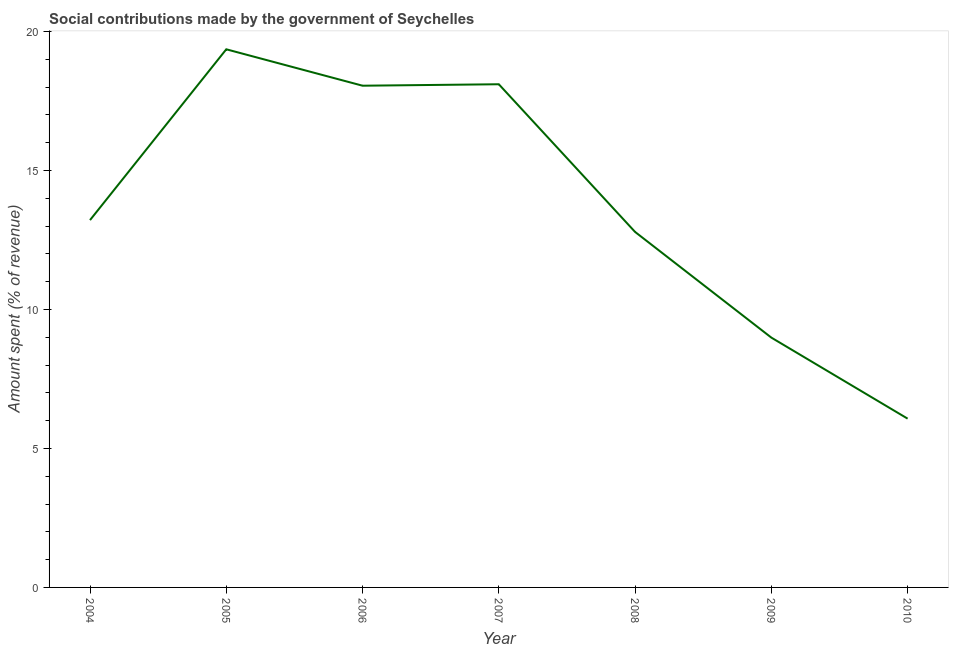What is the amount spent in making social contributions in 2008?
Give a very brief answer. 12.79. Across all years, what is the maximum amount spent in making social contributions?
Your answer should be compact. 19.36. Across all years, what is the minimum amount spent in making social contributions?
Provide a succinct answer. 6.07. In which year was the amount spent in making social contributions maximum?
Give a very brief answer. 2005. What is the sum of the amount spent in making social contributions?
Provide a short and direct response. 96.59. What is the difference between the amount spent in making social contributions in 2007 and 2010?
Give a very brief answer. 12.03. What is the average amount spent in making social contributions per year?
Offer a terse response. 13.8. What is the median amount spent in making social contributions?
Ensure brevity in your answer.  13.22. In how many years, is the amount spent in making social contributions greater than 1 %?
Provide a succinct answer. 7. What is the ratio of the amount spent in making social contributions in 2005 to that in 2006?
Provide a short and direct response. 1.07. Is the amount spent in making social contributions in 2007 less than that in 2010?
Offer a terse response. No. What is the difference between the highest and the second highest amount spent in making social contributions?
Offer a terse response. 1.26. What is the difference between the highest and the lowest amount spent in making social contributions?
Offer a terse response. 13.29. Does the amount spent in making social contributions monotonically increase over the years?
Provide a succinct answer. No. How many lines are there?
Your response must be concise. 1. What is the difference between two consecutive major ticks on the Y-axis?
Make the answer very short. 5. Are the values on the major ticks of Y-axis written in scientific E-notation?
Give a very brief answer. No. Does the graph contain grids?
Offer a terse response. No. What is the title of the graph?
Provide a succinct answer. Social contributions made by the government of Seychelles. What is the label or title of the Y-axis?
Keep it short and to the point. Amount spent (% of revenue). What is the Amount spent (% of revenue) in 2004?
Provide a succinct answer. 13.22. What is the Amount spent (% of revenue) in 2005?
Your answer should be compact. 19.36. What is the Amount spent (% of revenue) in 2006?
Ensure brevity in your answer.  18.05. What is the Amount spent (% of revenue) of 2007?
Make the answer very short. 18.1. What is the Amount spent (% of revenue) of 2008?
Offer a terse response. 12.79. What is the Amount spent (% of revenue) of 2009?
Offer a very short reply. 8.99. What is the Amount spent (% of revenue) in 2010?
Your answer should be very brief. 6.07. What is the difference between the Amount spent (% of revenue) in 2004 and 2005?
Offer a terse response. -6.15. What is the difference between the Amount spent (% of revenue) in 2004 and 2006?
Offer a terse response. -4.84. What is the difference between the Amount spent (% of revenue) in 2004 and 2007?
Your response must be concise. -4.89. What is the difference between the Amount spent (% of revenue) in 2004 and 2008?
Provide a short and direct response. 0.43. What is the difference between the Amount spent (% of revenue) in 2004 and 2009?
Ensure brevity in your answer.  4.23. What is the difference between the Amount spent (% of revenue) in 2004 and 2010?
Provide a short and direct response. 7.14. What is the difference between the Amount spent (% of revenue) in 2005 and 2006?
Offer a very short reply. 1.31. What is the difference between the Amount spent (% of revenue) in 2005 and 2007?
Make the answer very short. 1.26. What is the difference between the Amount spent (% of revenue) in 2005 and 2008?
Provide a succinct answer. 6.57. What is the difference between the Amount spent (% of revenue) in 2005 and 2009?
Your answer should be compact. 10.37. What is the difference between the Amount spent (% of revenue) in 2005 and 2010?
Your response must be concise. 13.29. What is the difference between the Amount spent (% of revenue) in 2006 and 2007?
Give a very brief answer. -0.05. What is the difference between the Amount spent (% of revenue) in 2006 and 2008?
Your answer should be very brief. 5.26. What is the difference between the Amount spent (% of revenue) in 2006 and 2009?
Provide a succinct answer. 9.06. What is the difference between the Amount spent (% of revenue) in 2006 and 2010?
Give a very brief answer. 11.98. What is the difference between the Amount spent (% of revenue) in 2007 and 2008?
Provide a short and direct response. 5.31. What is the difference between the Amount spent (% of revenue) in 2007 and 2009?
Your response must be concise. 9.12. What is the difference between the Amount spent (% of revenue) in 2007 and 2010?
Your response must be concise. 12.03. What is the difference between the Amount spent (% of revenue) in 2008 and 2009?
Your answer should be compact. 3.8. What is the difference between the Amount spent (% of revenue) in 2008 and 2010?
Your answer should be very brief. 6.72. What is the difference between the Amount spent (% of revenue) in 2009 and 2010?
Offer a terse response. 2.92. What is the ratio of the Amount spent (% of revenue) in 2004 to that in 2005?
Your answer should be compact. 0.68. What is the ratio of the Amount spent (% of revenue) in 2004 to that in 2006?
Give a very brief answer. 0.73. What is the ratio of the Amount spent (% of revenue) in 2004 to that in 2007?
Your response must be concise. 0.73. What is the ratio of the Amount spent (% of revenue) in 2004 to that in 2008?
Your answer should be very brief. 1.03. What is the ratio of the Amount spent (% of revenue) in 2004 to that in 2009?
Give a very brief answer. 1.47. What is the ratio of the Amount spent (% of revenue) in 2004 to that in 2010?
Your response must be concise. 2.18. What is the ratio of the Amount spent (% of revenue) in 2005 to that in 2006?
Your answer should be compact. 1.07. What is the ratio of the Amount spent (% of revenue) in 2005 to that in 2007?
Keep it short and to the point. 1.07. What is the ratio of the Amount spent (% of revenue) in 2005 to that in 2008?
Keep it short and to the point. 1.51. What is the ratio of the Amount spent (% of revenue) in 2005 to that in 2009?
Ensure brevity in your answer.  2.15. What is the ratio of the Amount spent (% of revenue) in 2005 to that in 2010?
Your answer should be very brief. 3.19. What is the ratio of the Amount spent (% of revenue) in 2006 to that in 2008?
Your response must be concise. 1.41. What is the ratio of the Amount spent (% of revenue) in 2006 to that in 2009?
Give a very brief answer. 2.01. What is the ratio of the Amount spent (% of revenue) in 2006 to that in 2010?
Make the answer very short. 2.97. What is the ratio of the Amount spent (% of revenue) in 2007 to that in 2008?
Give a very brief answer. 1.42. What is the ratio of the Amount spent (% of revenue) in 2007 to that in 2009?
Provide a short and direct response. 2.01. What is the ratio of the Amount spent (% of revenue) in 2007 to that in 2010?
Ensure brevity in your answer.  2.98. What is the ratio of the Amount spent (% of revenue) in 2008 to that in 2009?
Your response must be concise. 1.42. What is the ratio of the Amount spent (% of revenue) in 2008 to that in 2010?
Offer a very short reply. 2.11. What is the ratio of the Amount spent (% of revenue) in 2009 to that in 2010?
Provide a short and direct response. 1.48. 